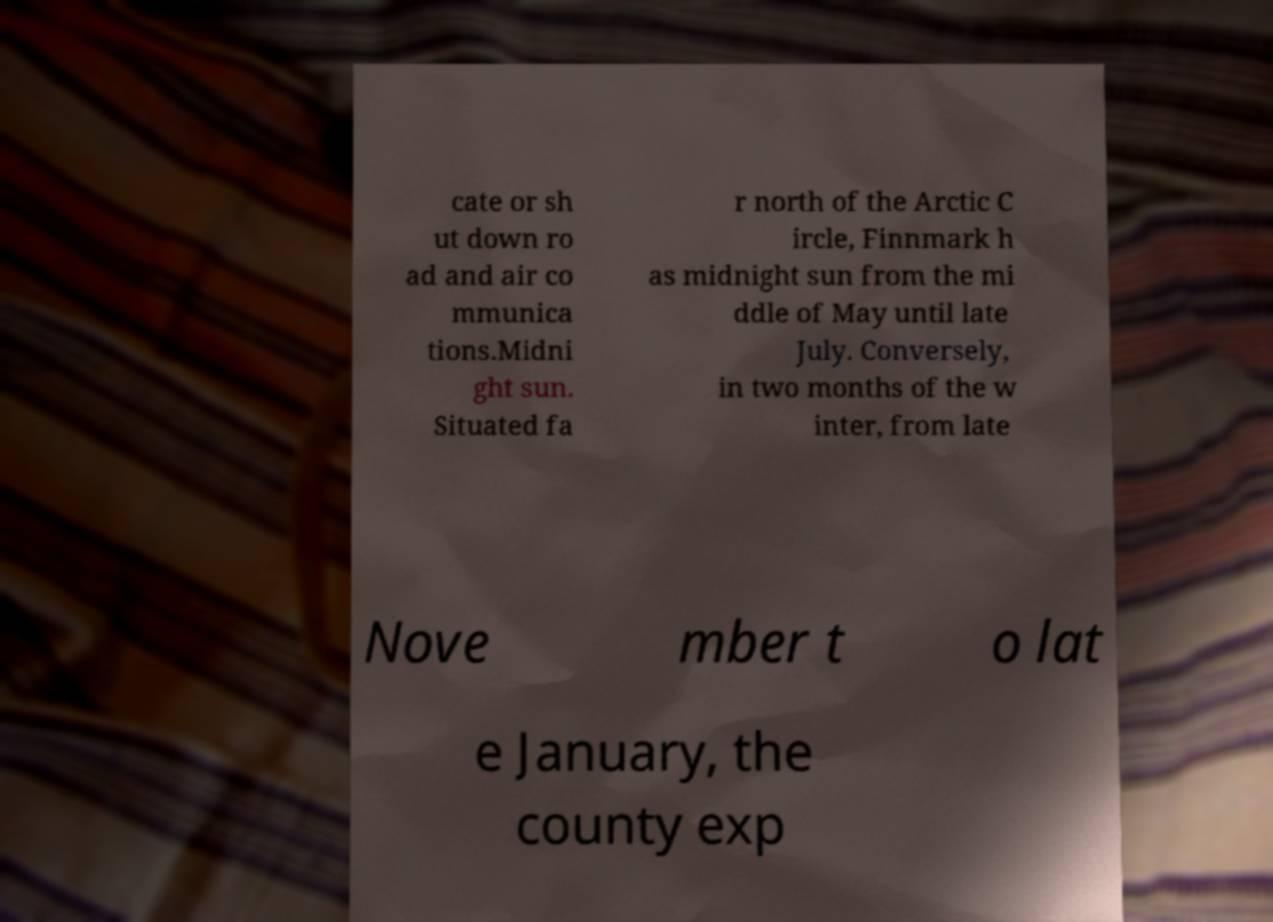Please read and relay the text visible in this image. What does it say? cate or sh ut down ro ad and air co mmunica tions.Midni ght sun. Situated fa r north of the Arctic C ircle, Finnmark h as midnight sun from the mi ddle of May until late July. Conversely, in two months of the w inter, from late Nove mber t o lat e January, the county exp 